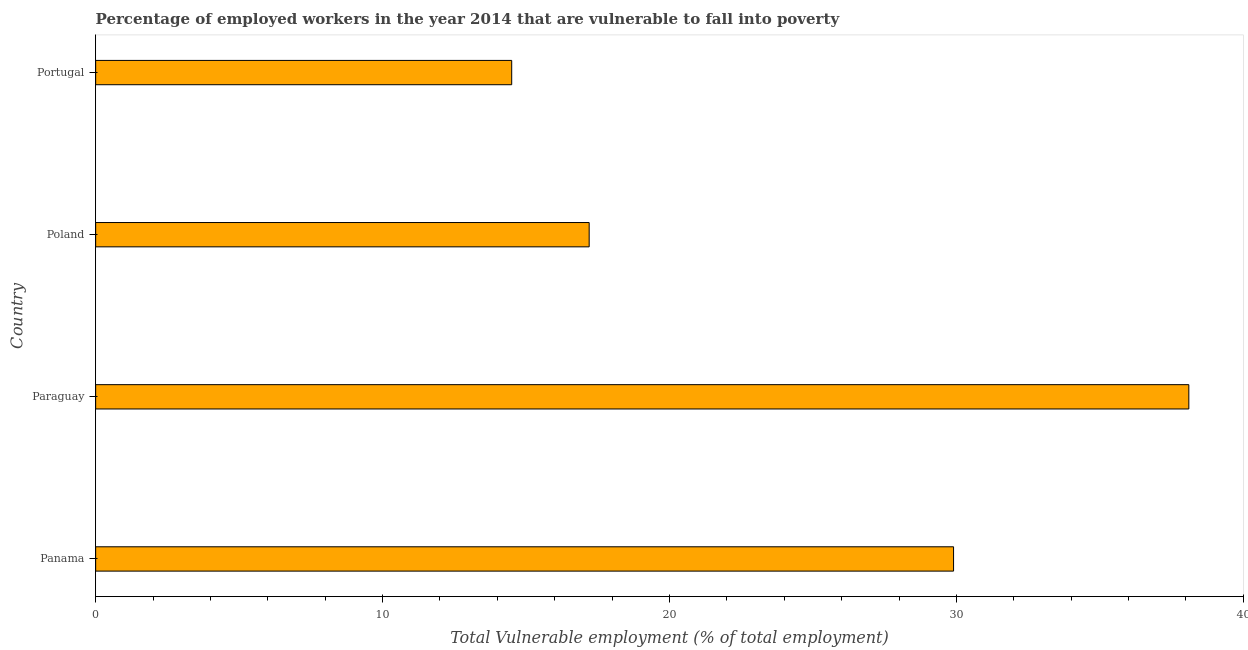Does the graph contain grids?
Offer a very short reply. No. What is the title of the graph?
Your response must be concise. Percentage of employed workers in the year 2014 that are vulnerable to fall into poverty. What is the label or title of the X-axis?
Keep it short and to the point. Total Vulnerable employment (% of total employment). What is the total vulnerable employment in Panama?
Ensure brevity in your answer.  29.9. Across all countries, what is the maximum total vulnerable employment?
Keep it short and to the point. 38.1. In which country was the total vulnerable employment maximum?
Make the answer very short. Paraguay. In which country was the total vulnerable employment minimum?
Make the answer very short. Portugal. What is the sum of the total vulnerable employment?
Provide a short and direct response. 99.7. What is the average total vulnerable employment per country?
Ensure brevity in your answer.  24.93. What is the median total vulnerable employment?
Ensure brevity in your answer.  23.55. In how many countries, is the total vulnerable employment greater than 20 %?
Offer a very short reply. 2. What is the ratio of the total vulnerable employment in Poland to that in Portugal?
Provide a succinct answer. 1.19. What is the difference between the highest and the second highest total vulnerable employment?
Your response must be concise. 8.2. Is the sum of the total vulnerable employment in Poland and Portugal greater than the maximum total vulnerable employment across all countries?
Your answer should be very brief. No. What is the difference between the highest and the lowest total vulnerable employment?
Give a very brief answer. 23.6. How many bars are there?
Your answer should be compact. 4. Are all the bars in the graph horizontal?
Provide a succinct answer. Yes. What is the difference between two consecutive major ticks on the X-axis?
Make the answer very short. 10. Are the values on the major ticks of X-axis written in scientific E-notation?
Provide a succinct answer. No. What is the Total Vulnerable employment (% of total employment) in Panama?
Your response must be concise. 29.9. What is the Total Vulnerable employment (% of total employment) of Paraguay?
Offer a very short reply. 38.1. What is the Total Vulnerable employment (% of total employment) in Poland?
Offer a very short reply. 17.2. What is the difference between the Total Vulnerable employment (% of total employment) in Panama and Paraguay?
Provide a succinct answer. -8.2. What is the difference between the Total Vulnerable employment (% of total employment) in Panama and Portugal?
Your answer should be very brief. 15.4. What is the difference between the Total Vulnerable employment (% of total employment) in Paraguay and Poland?
Your answer should be compact. 20.9. What is the difference between the Total Vulnerable employment (% of total employment) in Paraguay and Portugal?
Make the answer very short. 23.6. What is the ratio of the Total Vulnerable employment (% of total employment) in Panama to that in Paraguay?
Give a very brief answer. 0.79. What is the ratio of the Total Vulnerable employment (% of total employment) in Panama to that in Poland?
Your answer should be compact. 1.74. What is the ratio of the Total Vulnerable employment (% of total employment) in Panama to that in Portugal?
Your answer should be very brief. 2.06. What is the ratio of the Total Vulnerable employment (% of total employment) in Paraguay to that in Poland?
Offer a terse response. 2.21. What is the ratio of the Total Vulnerable employment (% of total employment) in Paraguay to that in Portugal?
Keep it short and to the point. 2.63. What is the ratio of the Total Vulnerable employment (% of total employment) in Poland to that in Portugal?
Give a very brief answer. 1.19. 